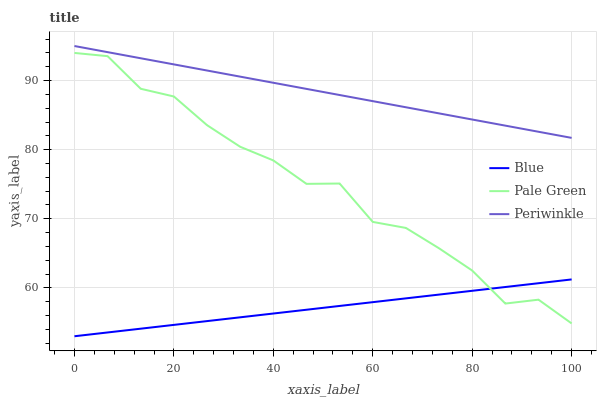Does Blue have the minimum area under the curve?
Answer yes or no. Yes. Does Pale Green have the minimum area under the curve?
Answer yes or no. No. Does Pale Green have the maximum area under the curve?
Answer yes or no. No. Is Periwinkle the smoothest?
Answer yes or no. Yes. Is Pale Green the roughest?
Answer yes or no. Yes. Is Pale Green the smoothest?
Answer yes or no. No. Is Periwinkle the roughest?
Answer yes or no. No. Does Pale Green have the lowest value?
Answer yes or no. No. Does Pale Green have the highest value?
Answer yes or no. No. Is Pale Green less than Periwinkle?
Answer yes or no. Yes. Is Periwinkle greater than Blue?
Answer yes or no. Yes. Does Pale Green intersect Periwinkle?
Answer yes or no. No. 